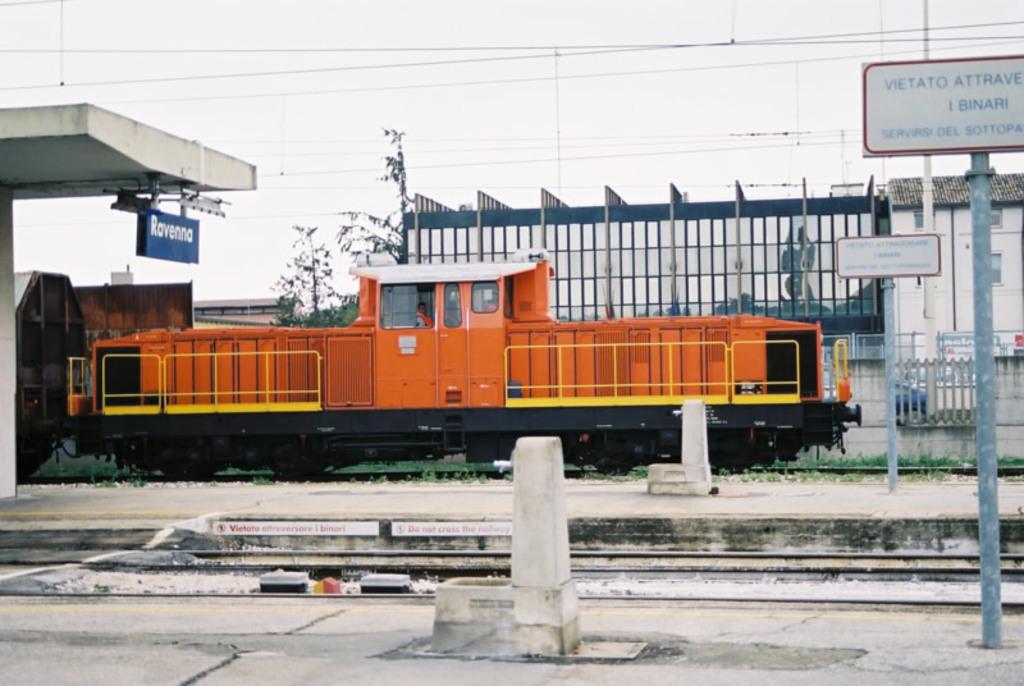What is on the blue sign?
Ensure brevity in your answer.  Ravenna. 